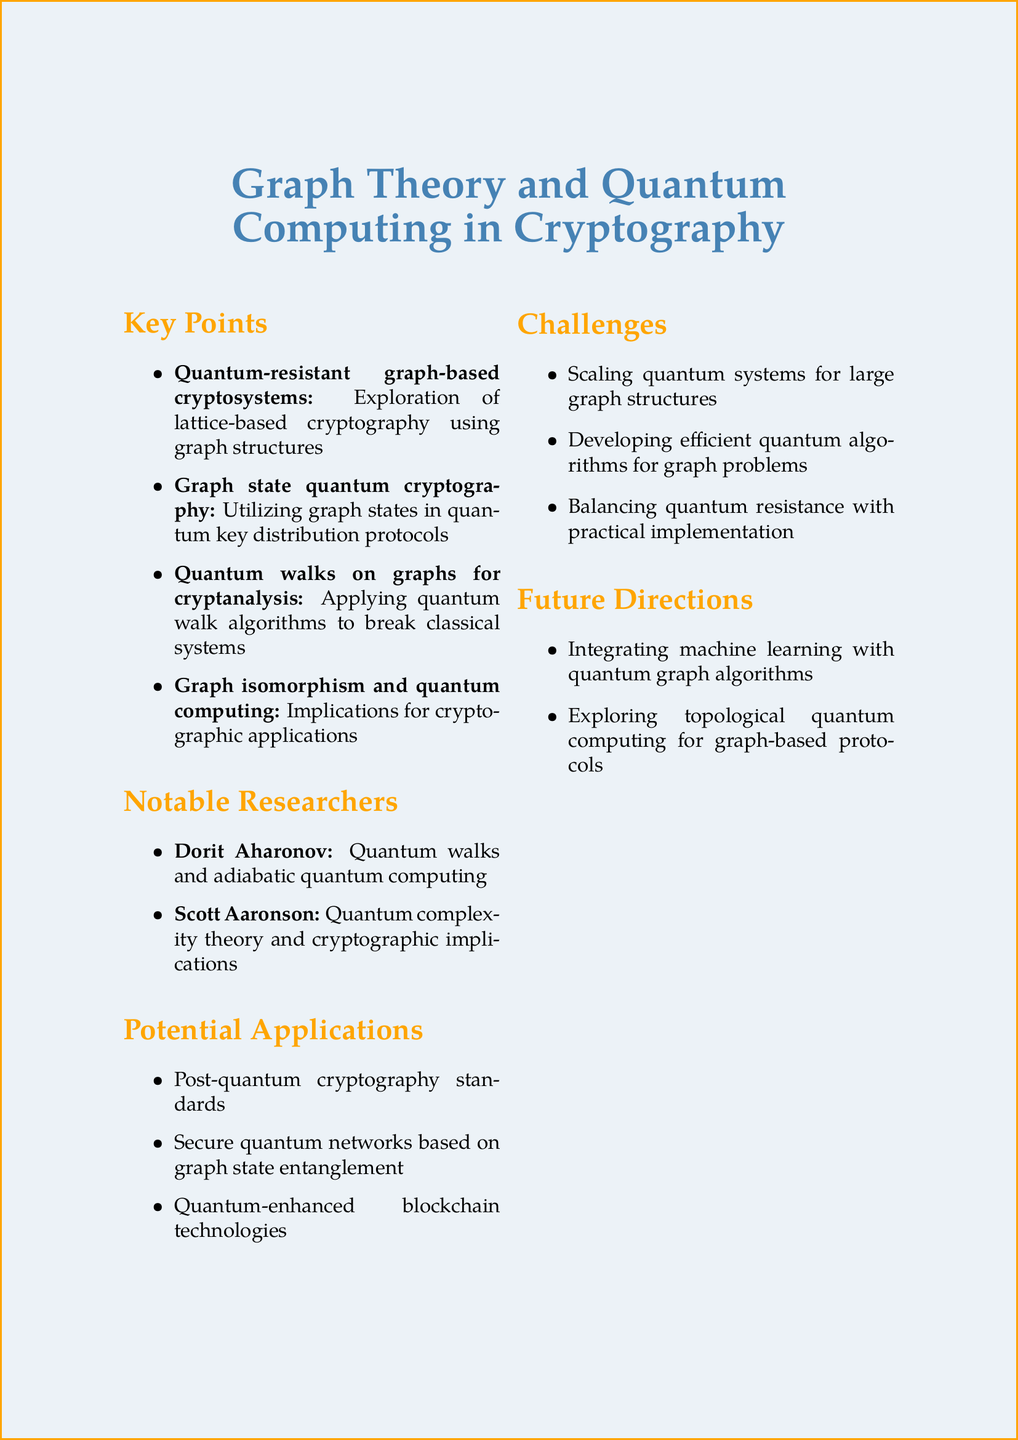What is the title of the document? The title appears at the top of the document, indicating the main subject of the notes.
Answer: Graph Theory and Quantum Computing in Cryptography Who is one of the notable researchers mentioned? The section on notable researchers lists individuals with significant contributions in the field.
Answer: Dorit Aharonov What is one of the potential applications of the topics discussed? Potential applications are listed under their own section, reflecting the practical uses of the research.
Answer: Post-quantum cryptography standards What challenge is mentioned regarding quantum systems? The section on challenges outlines specific issues that need to be addressed in the field.
Answer: Scaling quantum systems to handle large graph structures Which quantum algorithm is discussed in relation to cryptanalysis? Quantum walk algorithms are specifically noted in the context of breaking classical systems in the document.
Answer: Quantum walks on graphs What is one future direction suggested in the document? The future directions section articulates possible paths for further research and application.
Answer: Integration of machine learning with quantum graph algorithms What cryptographic problem is linked to graph isomorphism? The document discusses implications of quantum algorithms on a specific problem within cryptography.
Answer: Graph isomorphism What type of cryptographic systems does the document explore? The key points section highlights types of systems that are resistant to quantum attacks.
Answer: Quantum-resistant graph-based cryptosystems 